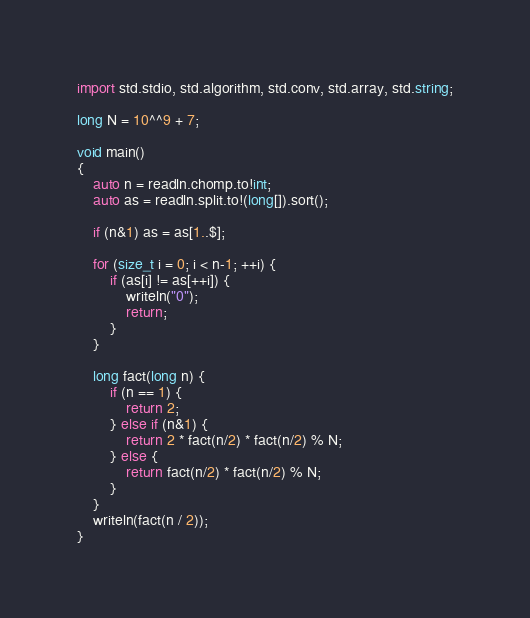Convert code to text. <code><loc_0><loc_0><loc_500><loc_500><_D_>import std.stdio, std.algorithm, std.conv, std.array, std.string;

long N = 10^^9 + 7;

void main()
{
    auto n = readln.chomp.to!int;
    auto as = readln.split.to!(long[]).sort();

    if (n&1) as = as[1..$];

    for (size_t i = 0; i < n-1; ++i) {
        if (as[i] != as[++i]) {
            writeln("0");
            return;
        }
    }

    long fact(long n) {
        if (n == 1) {
            return 2;
        } else if (n&1) {
            return 2 * fact(n/2) * fact(n/2) % N;
        } else {
            return fact(n/2) * fact(n/2) % N;
        }
    }
    writeln(fact(n / 2));
}</code> 